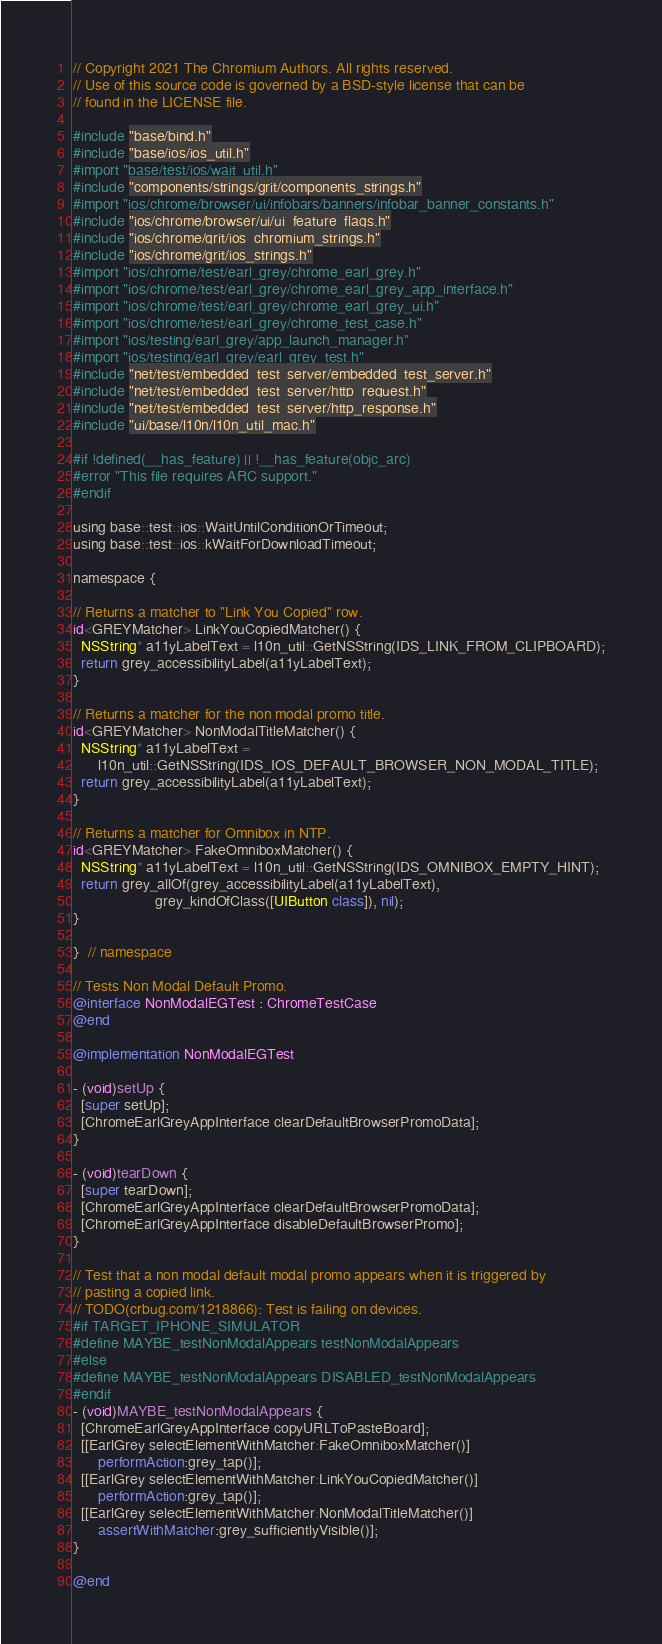Convert code to text. <code><loc_0><loc_0><loc_500><loc_500><_ObjectiveC_>// Copyright 2021 The Chromium Authors. All rights reserved.
// Use of this source code is governed by a BSD-style license that can be
// found in the LICENSE file.

#include "base/bind.h"
#include "base/ios/ios_util.h"
#import "base/test/ios/wait_util.h"
#include "components/strings/grit/components_strings.h"
#import "ios/chrome/browser/ui/infobars/banners/infobar_banner_constants.h"
#include "ios/chrome/browser/ui/ui_feature_flags.h"
#include "ios/chrome/grit/ios_chromium_strings.h"
#include "ios/chrome/grit/ios_strings.h"
#import "ios/chrome/test/earl_grey/chrome_earl_grey.h"
#import "ios/chrome/test/earl_grey/chrome_earl_grey_app_interface.h"
#import "ios/chrome/test/earl_grey/chrome_earl_grey_ui.h"
#import "ios/chrome/test/earl_grey/chrome_test_case.h"
#import "ios/testing/earl_grey/app_launch_manager.h"
#import "ios/testing/earl_grey/earl_grey_test.h"
#include "net/test/embedded_test_server/embedded_test_server.h"
#include "net/test/embedded_test_server/http_request.h"
#include "net/test/embedded_test_server/http_response.h"
#include "ui/base/l10n/l10n_util_mac.h"

#if !defined(__has_feature) || !__has_feature(objc_arc)
#error "This file requires ARC support."
#endif

using base::test::ios::WaitUntilConditionOrTimeout;
using base::test::ios::kWaitForDownloadTimeout;

namespace {

// Returns a matcher to "Link You Copied" row.
id<GREYMatcher> LinkYouCopiedMatcher() {
  NSString* a11yLabelText = l10n_util::GetNSString(IDS_LINK_FROM_CLIPBOARD);
  return grey_accessibilityLabel(a11yLabelText);
}

// Returns a matcher for the non modal promo title.
id<GREYMatcher> NonModalTitleMatcher() {
  NSString* a11yLabelText =
      l10n_util::GetNSString(IDS_IOS_DEFAULT_BROWSER_NON_MODAL_TITLE);
  return grey_accessibilityLabel(a11yLabelText);
}

// Returns a matcher for Omnibox in NTP.
id<GREYMatcher> FakeOmniboxMatcher() {
  NSString* a11yLabelText = l10n_util::GetNSString(IDS_OMNIBOX_EMPTY_HINT);
  return grey_allOf(grey_accessibilityLabel(a11yLabelText),
                    grey_kindOfClass([UIButton class]), nil);
}

}  // namespace

// Tests Non Modal Default Promo.
@interface NonModalEGTest : ChromeTestCase
@end

@implementation NonModalEGTest

- (void)setUp {
  [super setUp];
  [ChromeEarlGreyAppInterface clearDefaultBrowserPromoData];
}

- (void)tearDown {
  [super tearDown];
  [ChromeEarlGreyAppInterface clearDefaultBrowserPromoData];
  [ChromeEarlGreyAppInterface disableDefaultBrowserPromo];
}

// Test that a non modal default modal promo appears when it is triggered by
// pasting a copied link.
// TODO(crbug.com/1218866): Test is failing on devices.
#if TARGET_IPHONE_SIMULATOR
#define MAYBE_testNonModalAppears testNonModalAppears
#else
#define MAYBE_testNonModalAppears DISABLED_testNonModalAppears
#endif
- (void)MAYBE_testNonModalAppears {
  [ChromeEarlGreyAppInterface copyURLToPasteBoard];
  [[EarlGrey selectElementWithMatcher:FakeOmniboxMatcher()]
      performAction:grey_tap()];
  [[EarlGrey selectElementWithMatcher:LinkYouCopiedMatcher()]
      performAction:grey_tap()];
  [[EarlGrey selectElementWithMatcher:NonModalTitleMatcher()]
      assertWithMatcher:grey_sufficientlyVisible()];
}

@end
</code> 